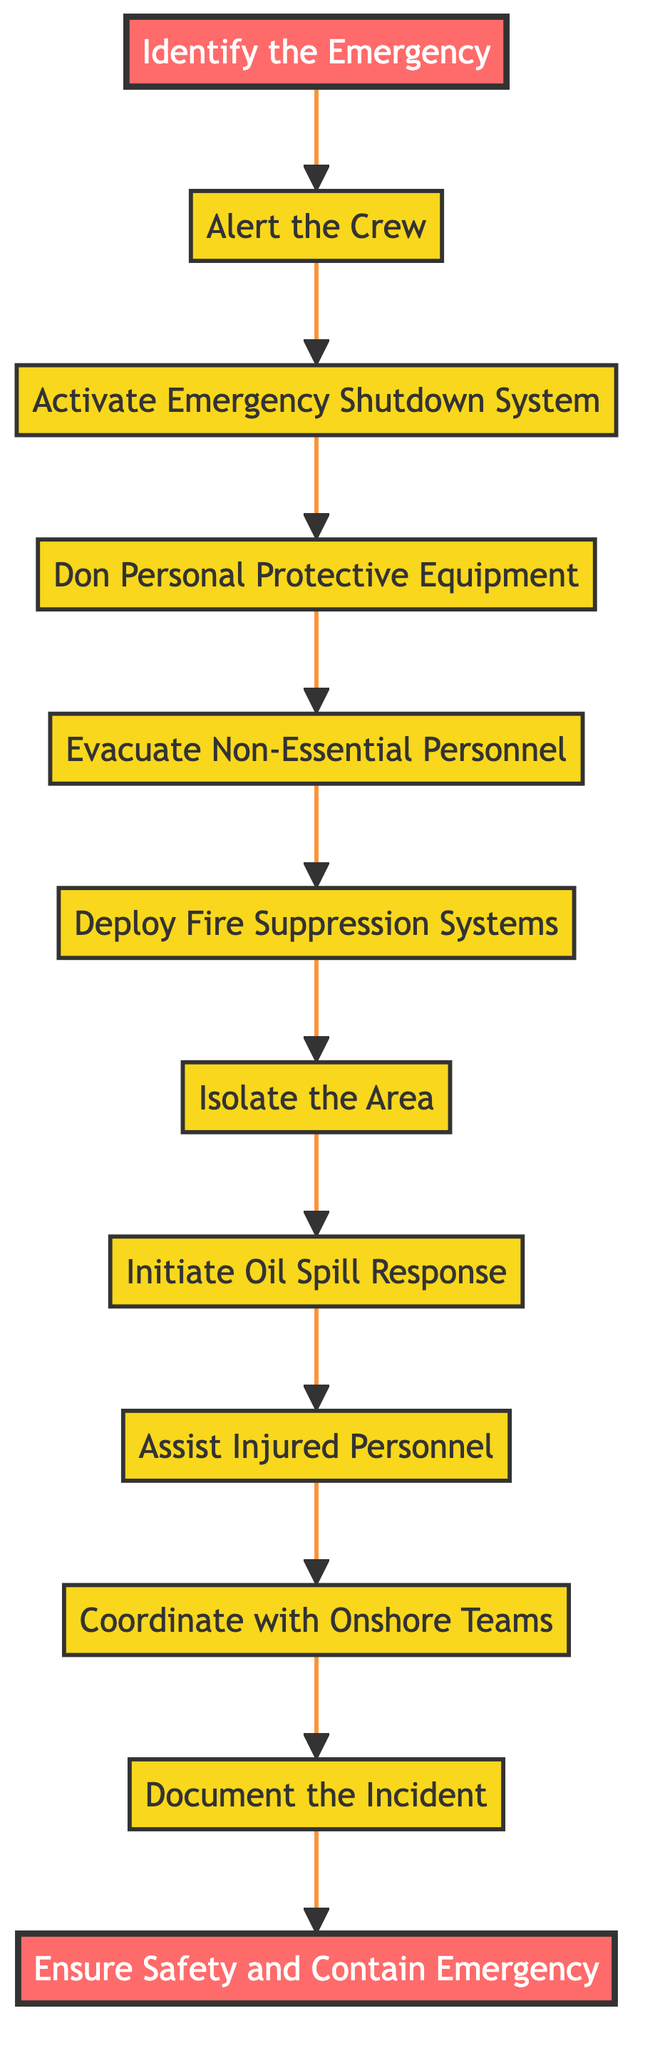What's the first step in the flowchart? The diagram starts with the "Identify the Emergency" node, indicating that this is the first action to take in the emergency protocol.
Answer: Identify the Emergency How many steps are there in total? Counting each node from "Identify the Emergency" to "Ensure Safety and Contain Emergency," there are a total of 11 steps including the trigger event and end goal.
Answer: 11 What action follows "Evacuate Non-Essential Personnel"? The flowchart shows that after "Evacuate Non-Essential Personnel," the next step is to "Deploy Fire Suppression Systems."
Answer: Deploy Fire Suppression Systems What is the last step of the flowchart? The final action listed in the flowchart is "Ensure Safety and Contain Emergency," indicating that this is the end goal of the emergency response protocol.
Answer: Ensure Safety and Contain Emergency Which step occurs after activating the Emergency Shutdown System? According to the flowchart, after "Activate the Emergency Shutdown System," the next action is to "Don Personal Protective Equipment."
Answer: Don Personal Protective Equipment What is the role of the "Coordinate with Onshore Emergency Response Teams" step? This step is part of the sequence that ensures comprehensive emergency communication and coordination with teams who are not on the rig, thus enhancing the emergency response.
Answer: Ensure communication and coordination If "Assist Injured Personnel" is successful, what step immediately follows? Once "Assist Injured Personnel" is completed, the next designated action in the flowchart is "Coordinate with Onshore Emergency Response Teams."
Answer: Coordinate with Onshore Emergency Response Teams What happens if an oil spill occurs during an emergency? If applicable, the flowchart indicates that after isolating the area, the specific step to follow is "Initiate Oil Spill Response."
Answer: Initiate Oil Spill Response What is the purpose of the Emergency Shutdown System step? This step is significant as it minimizes hazards by shutting down operations and preventing further danger in an emergency situation.
Answer: Minimize hazards 